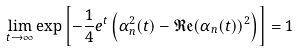Convert formula to latex. <formula><loc_0><loc_0><loc_500><loc_500>\lim _ { t \rightarrow \infty } \exp \left [ - \frac { 1 } { 4 } e ^ { t } \left ( \alpha _ { n } ^ { 2 } ( t ) - \mathfrak { R e } ( \alpha _ { n } ( t ) ) ^ { 2 } \right ) \right ] = 1</formula> 